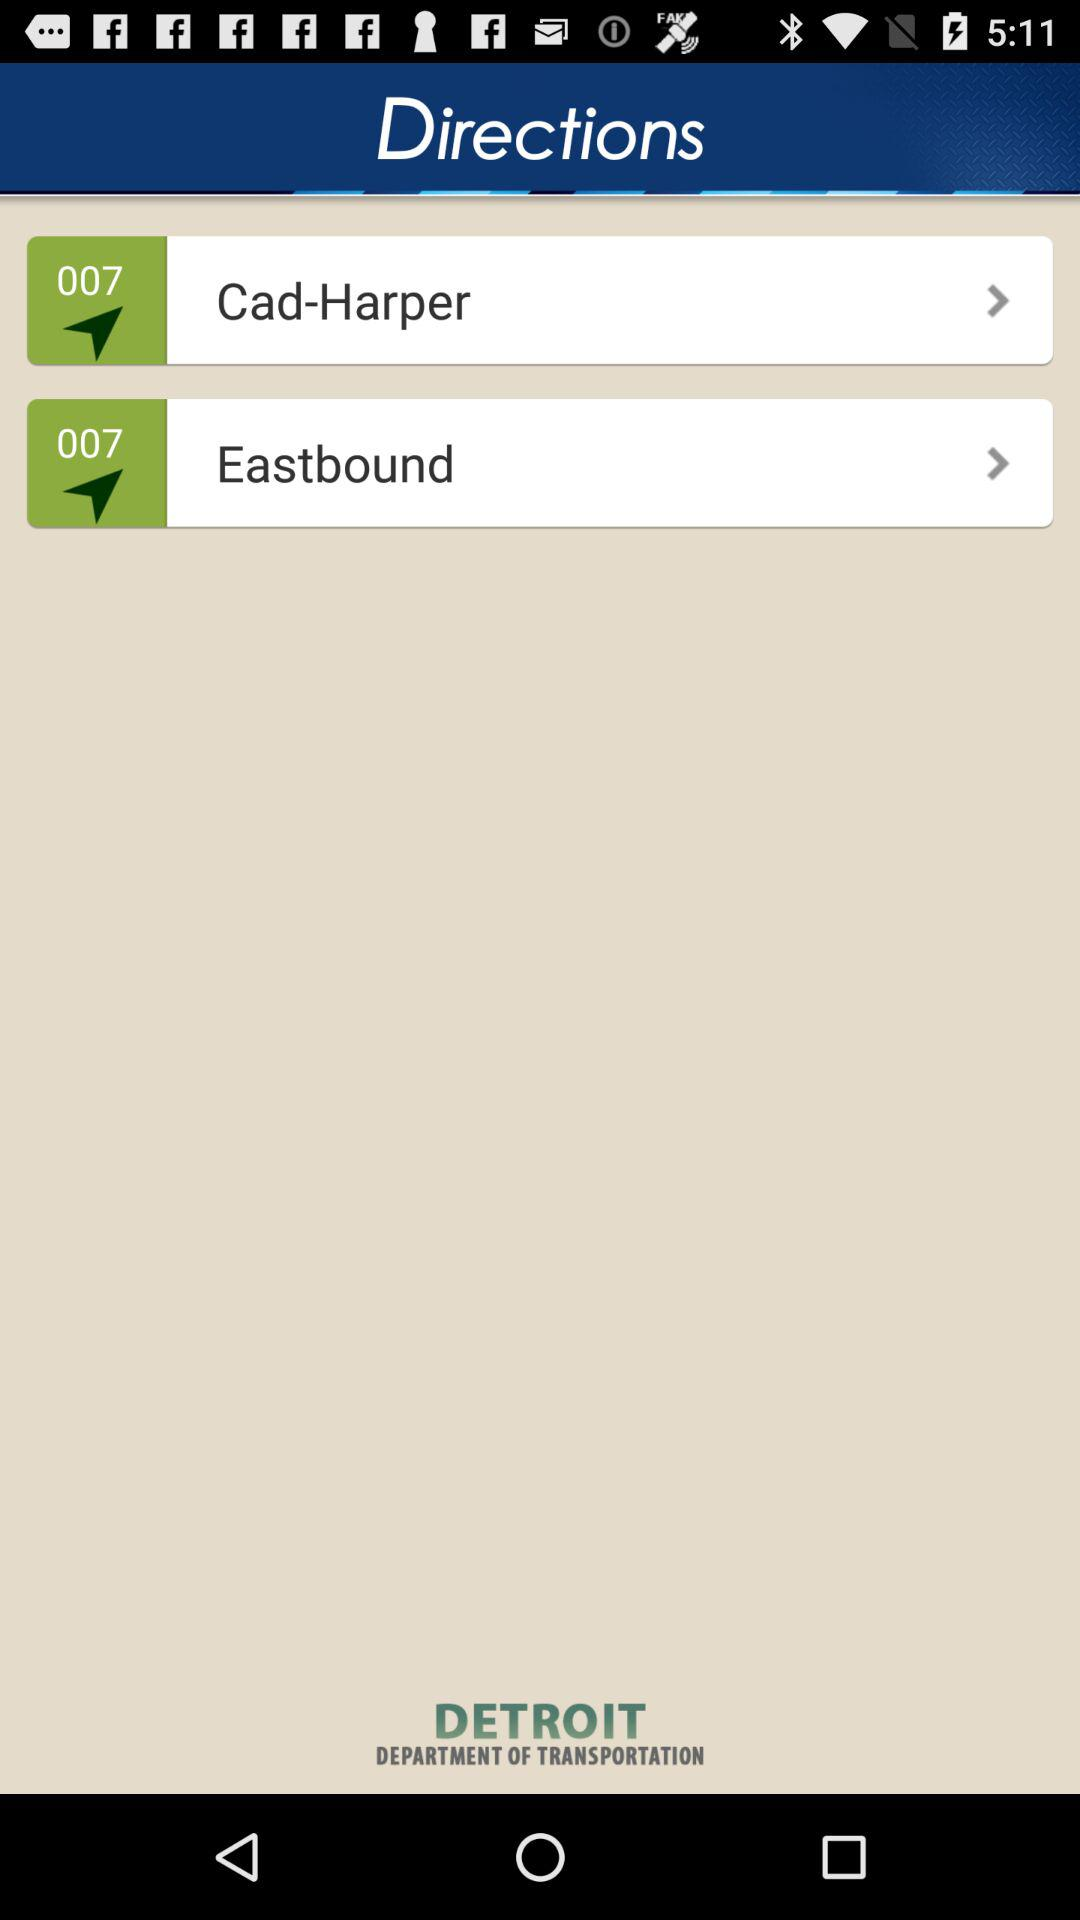What is the name of the application?
When the provided information is insufficient, respond with <no answer>. <no answer> 